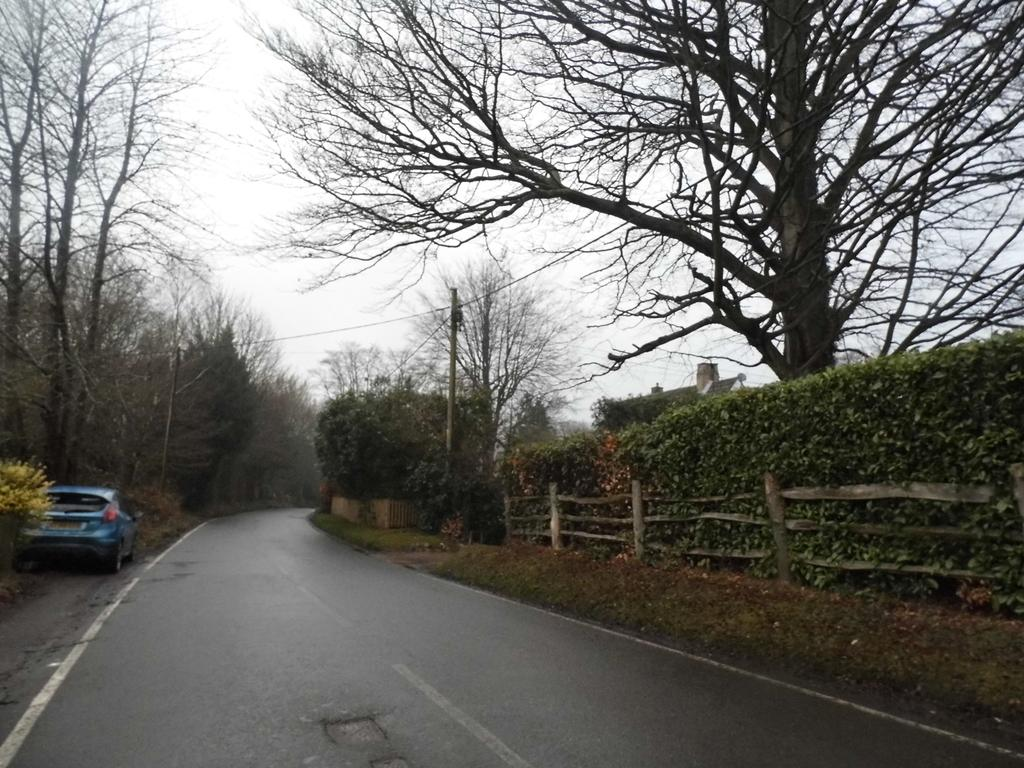What type of vegetation can be seen in the image? There are trees in the image. What mode of transportation is present on the road in the image? There is a car on the road in the image. What is visible in the background of the image? The sky is visible in the image. How many kittens are playing with eggs in the image? There are no kittens or eggs present in the image. What type of cows can be seen grazing in the background of the image? There are no cows present in the image; it only features trees, a car, and the sky. 